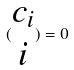Convert formula to latex. <formula><loc_0><loc_0><loc_500><loc_500>( \begin{matrix} c _ { i } \\ i \end{matrix} ) = 0</formula> 